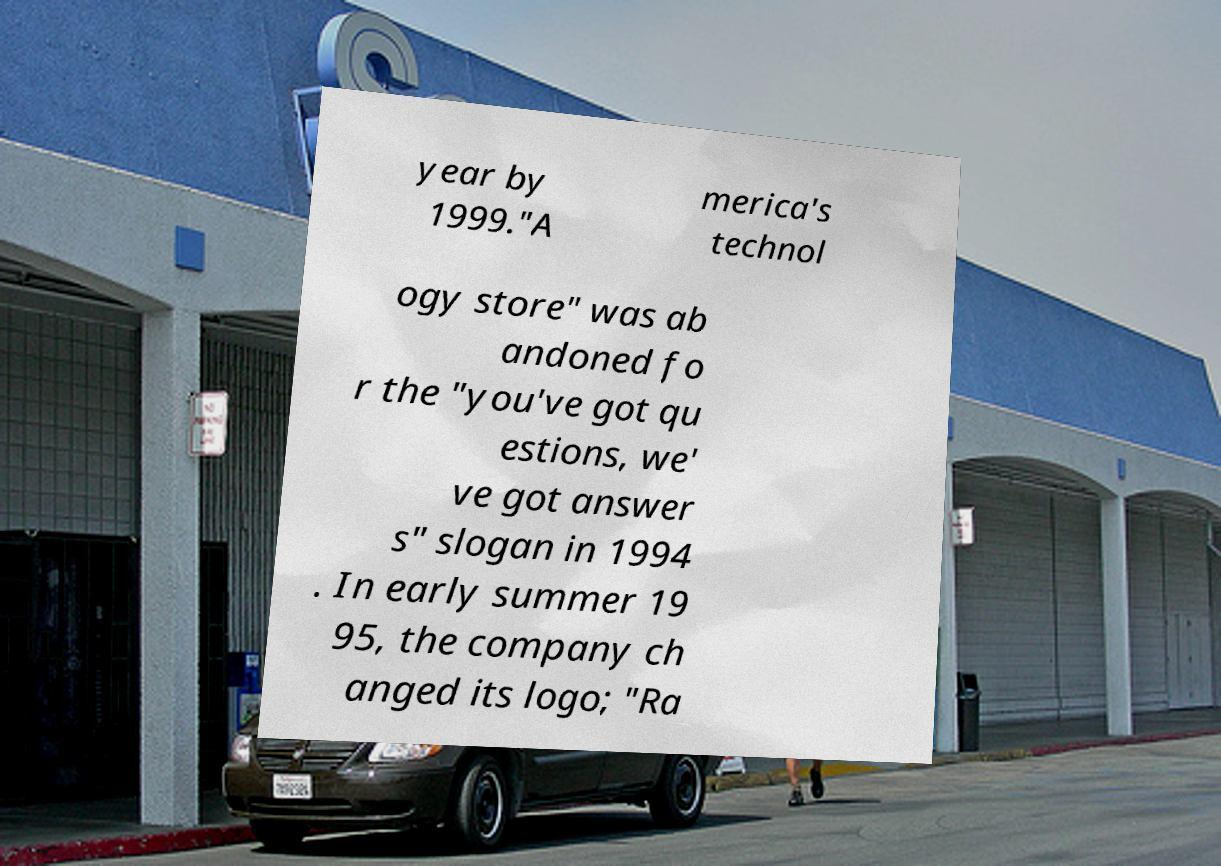For documentation purposes, I need the text within this image transcribed. Could you provide that? year by 1999."A merica's technol ogy store" was ab andoned fo r the "you've got qu estions, we' ve got answer s" slogan in 1994 . In early summer 19 95, the company ch anged its logo; "Ra 